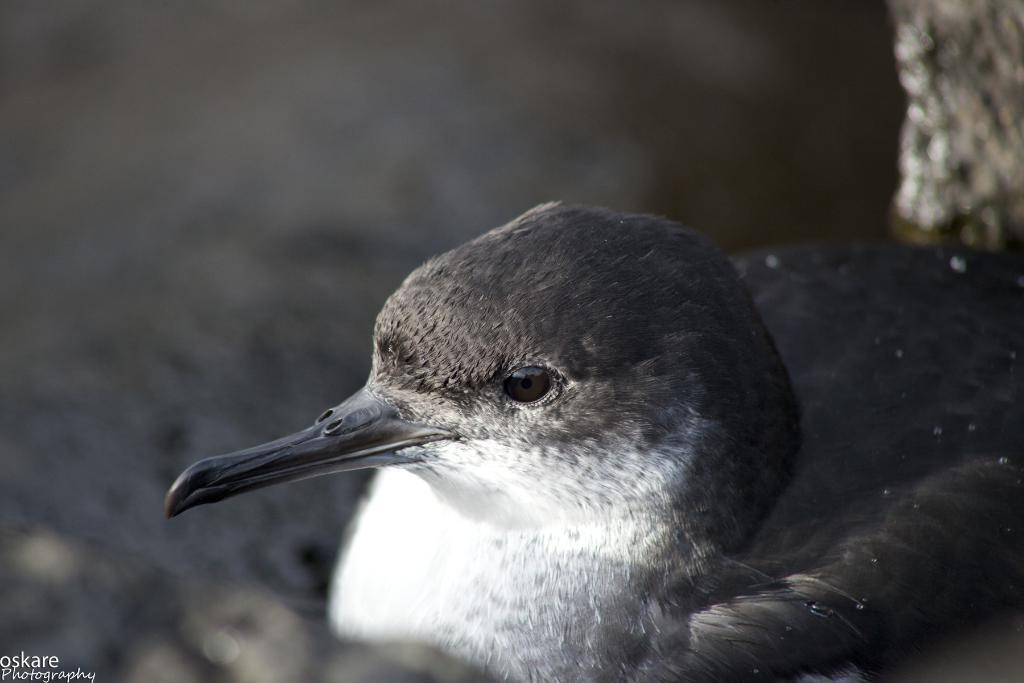What type of animal can be seen in the image? There is a bird in the image. Is there any text or marking in the image? Yes, there is a watermark in the bottom left corner of the image. How would you describe the background of the image? The background of the image is blurred. What type of berry is the bird holding in its beak in the image? There is no berry present in the image, nor is the bird holding anything in its beak. 